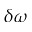<formula> <loc_0><loc_0><loc_500><loc_500>\delta \omega</formula> 